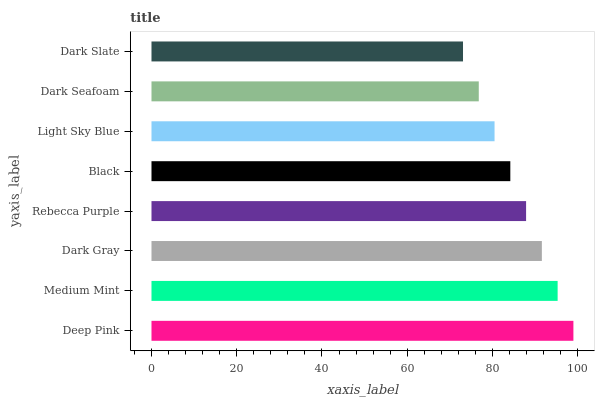Is Dark Slate the minimum?
Answer yes or no. Yes. Is Deep Pink the maximum?
Answer yes or no. Yes. Is Medium Mint the minimum?
Answer yes or no. No. Is Medium Mint the maximum?
Answer yes or no. No. Is Deep Pink greater than Medium Mint?
Answer yes or no. Yes. Is Medium Mint less than Deep Pink?
Answer yes or no. Yes. Is Medium Mint greater than Deep Pink?
Answer yes or no. No. Is Deep Pink less than Medium Mint?
Answer yes or no. No. Is Rebecca Purple the high median?
Answer yes or no. Yes. Is Black the low median?
Answer yes or no. Yes. Is Deep Pink the high median?
Answer yes or no. No. Is Rebecca Purple the low median?
Answer yes or no. No. 